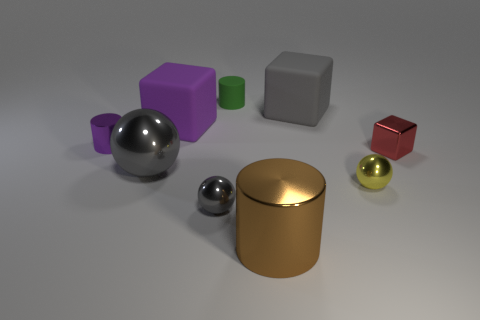There is a small metal thing that is on the left side of the tiny red shiny cube and right of the brown object; what shape is it?
Give a very brief answer. Sphere. What size is the metal cylinder behind the small gray metal object?
Offer a very short reply. Small. Do the green rubber cylinder and the brown cylinder have the same size?
Give a very brief answer. No. Are there fewer purple cylinders that are behind the purple rubber cube than big objects left of the tiny rubber thing?
Your answer should be very brief. Yes. There is a cylinder that is both on the left side of the big metallic cylinder and right of the small gray metal ball; what size is it?
Your answer should be compact. Small. There is a gray metallic sphere that is on the left side of the block that is left of the big shiny cylinder; is there a tiny yellow metallic object in front of it?
Your response must be concise. Yes. Are any red things visible?
Make the answer very short. Yes. Are there more gray balls in front of the red object than large brown metal cylinders behind the small green rubber cylinder?
Your answer should be compact. Yes. There is another block that is made of the same material as the big gray cube; what is its size?
Offer a terse response. Large. There is a thing that is on the right side of the sphere that is on the right side of the large gray object behind the purple cylinder; what size is it?
Provide a succinct answer. Small. 